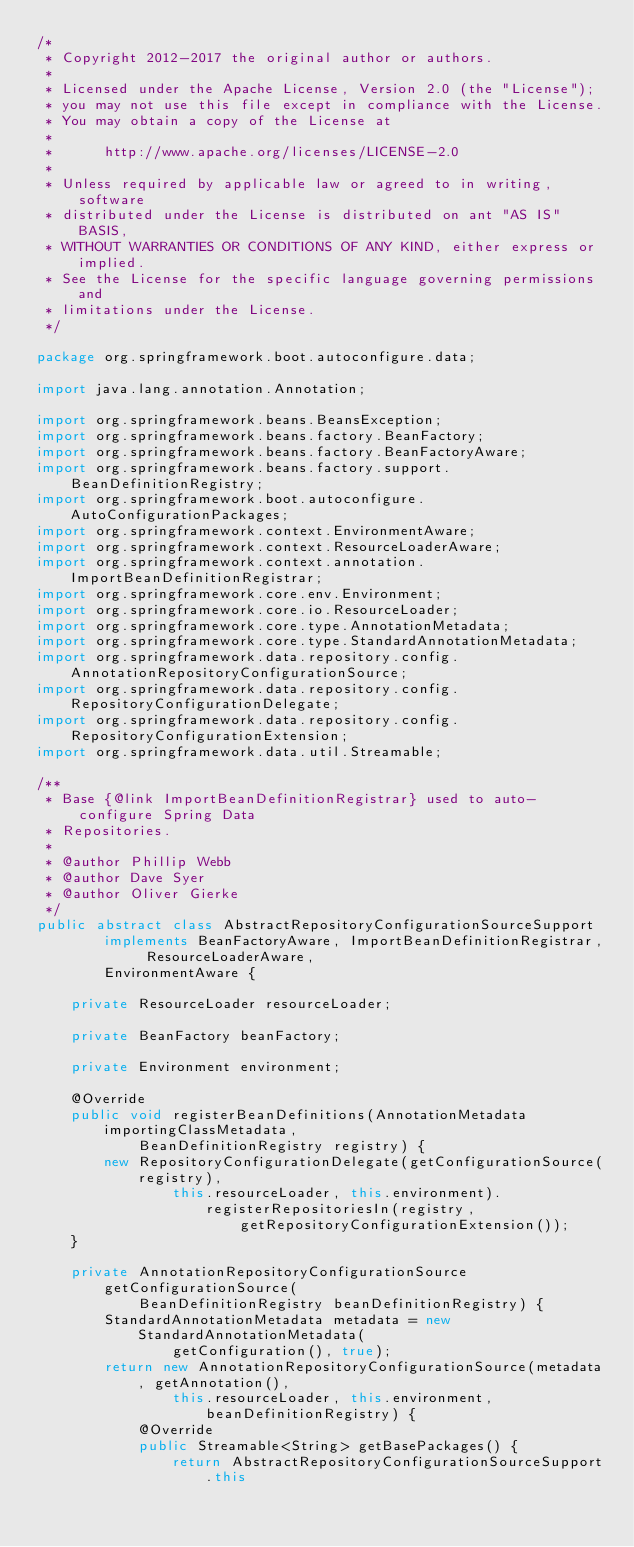<code> <loc_0><loc_0><loc_500><loc_500><_Java_>/*
 * Copyright 2012-2017 the original author or authors.
 *
 * Licensed under the Apache License, Version 2.0 (the "License");
 * you may not use this file except in compliance with the License.
 * You may obtain a copy of the License at
 *
 *      http://www.apache.org/licenses/LICENSE-2.0
 *
 * Unless required by applicable law or agreed to in writing, software
 * distributed under the License is distributed on ant "AS IS" BASIS,
 * WITHOUT WARRANTIES OR CONDITIONS OF ANY KIND, either express or implied.
 * See the License for the specific language governing permissions and
 * limitations under the License.
 */

package org.springframework.boot.autoconfigure.data;

import java.lang.annotation.Annotation;

import org.springframework.beans.BeansException;
import org.springframework.beans.factory.BeanFactory;
import org.springframework.beans.factory.BeanFactoryAware;
import org.springframework.beans.factory.support.BeanDefinitionRegistry;
import org.springframework.boot.autoconfigure.AutoConfigurationPackages;
import org.springframework.context.EnvironmentAware;
import org.springframework.context.ResourceLoaderAware;
import org.springframework.context.annotation.ImportBeanDefinitionRegistrar;
import org.springframework.core.env.Environment;
import org.springframework.core.io.ResourceLoader;
import org.springframework.core.type.AnnotationMetadata;
import org.springframework.core.type.StandardAnnotationMetadata;
import org.springframework.data.repository.config.AnnotationRepositoryConfigurationSource;
import org.springframework.data.repository.config.RepositoryConfigurationDelegate;
import org.springframework.data.repository.config.RepositoryConfigurationExtension;
import org.springframework.data.util.Streamable;

/**
 * Base {@link ImportBeanDefinitionRegistrar} used to auto-configure Spring Data
 * Repositories.
 *
 * @author Phillip Webb
 * @author Dave Syer
 * @author Oliver Gierke
 */
public abstract class AbstractRepositoryConfigurationSourceSupport
		implements BeanFactoryAware, ImportBeanDefinitionRegistrar, ResourceLoaderAware,
		EnvironmentAware {

	private ResourceLoader resourceLoader;

	private BeanFactory beanFactory;

	private Environment environment;

	@Override
	public void registerBeanDefinitions(AnnotationMetadata importingClassMetadata,
			BeanDefinitionRegistry registry) {
		new RepositoryConfigurationDelegate(getConfigurationSource(registry),
				this.resourceLoader, this.environment).registerRepositoriesIn(registry,
						getRepositoryConfigurationExtension());
	}

	private AnnotationRepositoryConfigurationSource getConfigurationSource(
			BeanDefinitionRegistry beanDefinitionRegistry) {
		StandardAnnotationMetadata metadata = new StandardAnnotationMetadata(
				getConfiguration(), true);
		return new AnnotationRepositoryConfigurationSource(metadata, getAnnotation(),
				this.resourceLoader, this.environment, beanDefinitionRegistry) {
			@Override
			public Streamable<String> getBasePackages() {
				return AbstractRepositoryConfigurationSourceSupport.this</code> 